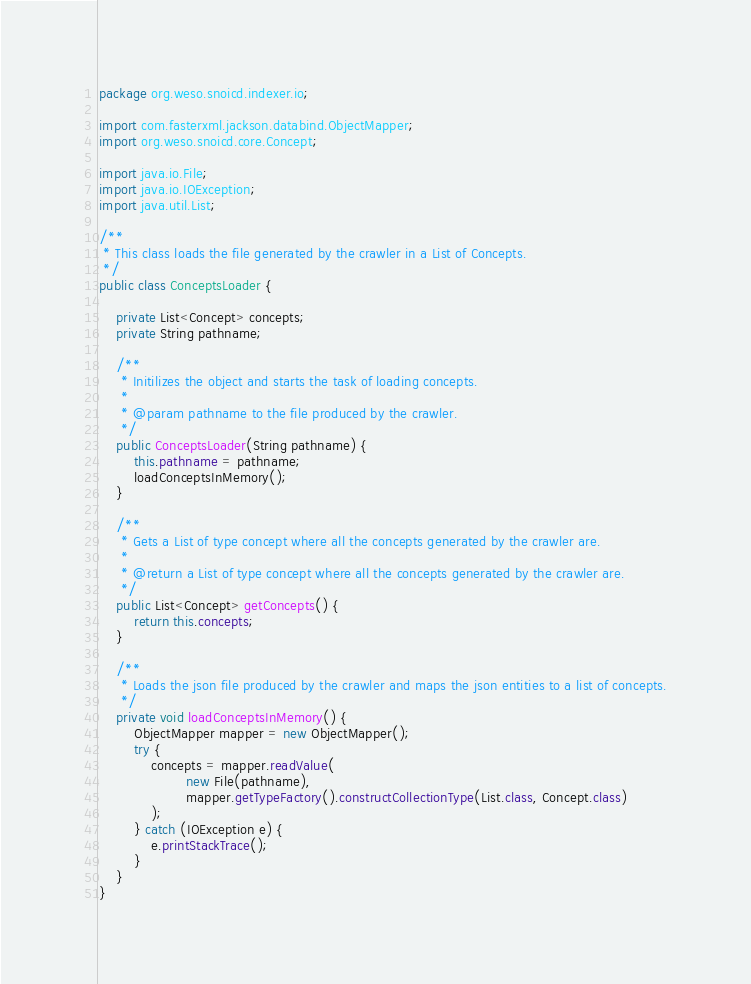Convert code to text. <code><loc_0><loc_0><loc_500><loc_500><_Java_>package org.weso.snoicd.indexer.io;

import com.fasterxml.jackson.databind.ObjectMapper;
import org.weso.snoicd.core.Concept;

import java.io.File;
import java.io.IOException;
import java.util.List;

/**
 * This class loads the file generated by the crawler in a List of Concepts.
 */
public class ConceptsLoader {

    private List<Concept> concepts;
    private String pathname;

    /**
     * Initilizes the object and starts the task of loading concepts.
     *
     * @param pathname to the file produced by the crawler.
     */
    public ConceptsLoader(String pathname) {
        this.pathname = pathname;
        loadConceptsInMemory();
    }

    /**
     * Gets a List of type concept where all the concepts generated by the crawler are.
     *
     * @return a List of type concept where all the concepts generated by the crawler are.
     */
    public List<Concept> getConcepts() {
        return this.concepts;
    }

    /**
     * Loads the json file produced by the crawler and maps the json entities to a list of concepts.
     */
    private void loadConceptsInMemory() {
        ObjectMapper mapper = new ObjectMapper();
        try {
            concepts = mapper.readValue(
                    new File(pathname),
                    mapper.getTypeFactory().constructCollectionType(List.class, Concept.class)
            );
        } catch (IOException e) {
            e.printStackTrace();
        }
    }
}
</code> 